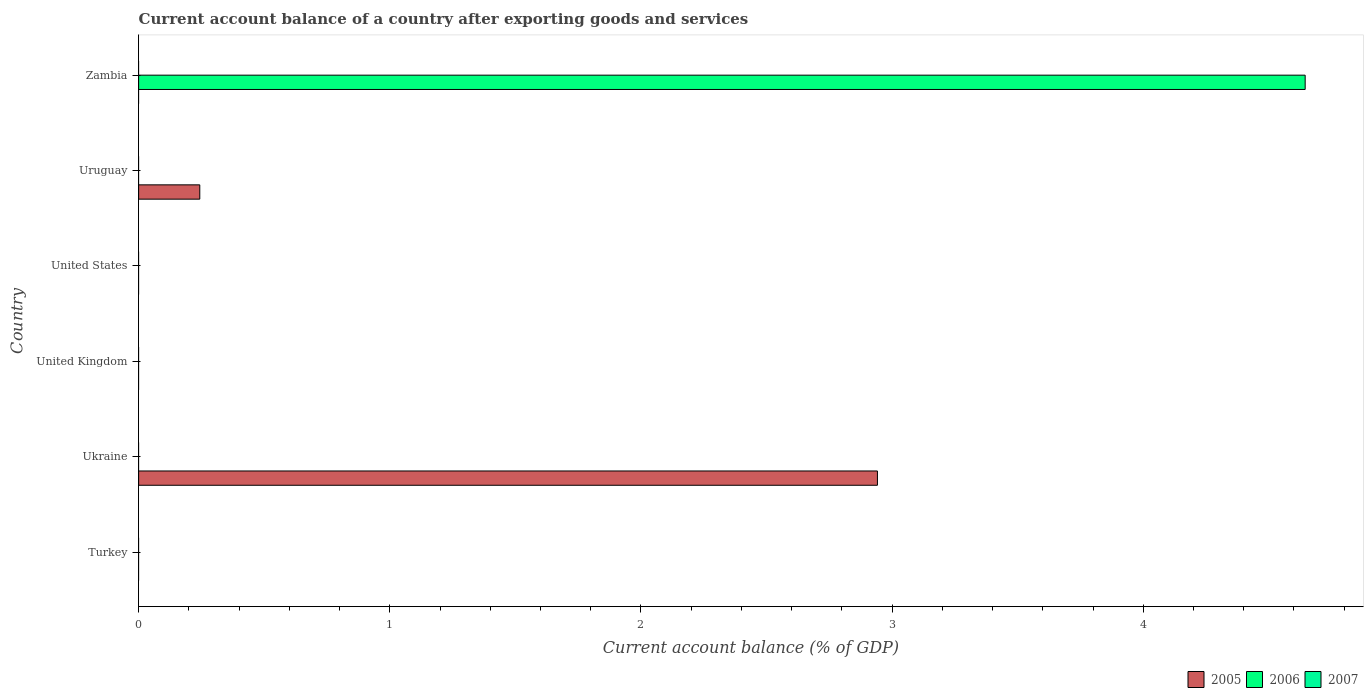How many different coloured bars are there?
Offer a terse response. 2. Are the number of bars on each tick of the Y-axis equal?
Your answer should be very brief. No. How many bars are there on the 2nd tick from the top?
Give a very brief answer. 1. What is the label of the 6th group of bars from the top?
Offer a very short reply. Turkey. In how many cases, is the number of bars for a given country not equal to the number of legend labels?
Provide a short and direct response. 6. Across all countries, what is the maximum account balance in 2005?
Your answer should be very brief. 2.94. In which country was the account balance in 2005 maximum?
Offer a terse response. Ukraine. What is the difference between the account balance in 2005 in Uruguay and the account balance in 2007 in Zambia?
Your answer should be very brief. 0.24. What is the average account balance in 2005 per country?
Provide a short and direct response. 0.53. In how many countries, is the account balance in 2007 greater than 0.8 %?
Give a very brief answer. 0. What is the difference between the highest and the lowest account balance in 2005?
Ensure brevity in your answer.  2.94. How many bars are there?
Provide a short and direct response. 3. How many countries are there in the graph?
Your answer should be compact. 6. Are the values on the major ticks of X-axis written in scientific E-notation?
Your response must be concise. No. Does the graph contain any zero values?
Offer a terse response. Yes. How are the legend labels stacked?
Offer a very short reply. Horizontal. What is the title of the graph?
Provide a short and direct response. Current account balance of a country after exporting goods and services. What is the label or title of the X-axis?
Offer a very short reply. Current account balance (% of GDP). What is the label or title of the Y-axis?
Keep it short and to the point. Country. What is the Current account balance (% of GDP) in 2006 in Turkey?
Provide a short and direct response. 0. What is the Current account balance (% of GDP) of 2005 in Ukraine?
Ensure brevity in your answer.  2.94. What is the Current account balance (% of GDP) in 2005 in United Kingdom?
Ensure brevity in your answer.  0. What is the Current account balance (% of GDP) in 2007 in United Kingdom?
Make the answer very short. 0. What is the Current account balance (% of GDP) in 2005 in United States?
Provide a short and direct response. 0. What is the Current account balance (% of GDP) of 2005 in Uruguay?
Keep it short and to the point. 0.24. What is the Current account balance (% of GDP) in 2006 in Zambia?
Give a very brief answer. 4.64. What is the Current account balance (% of GDP) in 2007 in Zambia?
Offer a very short reply. 0. Across all countries, what is the maximum Current account balance (% of GDP) in 2005?
Offer a terse response. 2.94. Across all countries, what is the maximum Current account balance (% of GDP) of 2006?
Provide a short and direct response. 4.64. What is the total Current account balance (% of GDP) of 2005 in the graph?
Provide a succinct answer. 3.19. What is the total Current account balance (% of GDP) of 2006 in the graph?
Offer a very short reply. 4.64. What is the total Current account balance (% of GDP) in 2007 in the graph?
Offer a very short reply. 0. What is the difference between the Current account balance (% of GDP) in 2005 in Ukraine and that in Uruguay?
Provide a short and direct response. 2.7. What is the difference between the Current account balance (% of GDP) in 2005 in Ukraine and the Current account balance (% of GDP) in 2006 in Zambia?
Give a very brief answer. -1.7. What is the difference between the Current account balance (% of GDP) in 2005 in Uruguay and the Current account balance (% of GDP) in 2006 in Zambia?
Your response must be concise. -4.4. What is the average Current account balance (% of GDP) of 2005 per country?
Your answer should be very brief. 0.53. What is the average Current account balance (% of GDP) in 2006 per country?
Provide a short and direct response. 0.77. What is the ratio of the Current account balance (% of GDP) of 2005 in Ukraine to that in Uruguay?
Your answer should be compact. 12.08. What is the difference between the highest and the lowest Current account balance (% of GDP) of 2005?
Provide a short and direct response. 2.94. What is the difference between the highest and the lowest Current account balance (% of GDP) in 2006?
Provide a short and direct response. 4.64. 